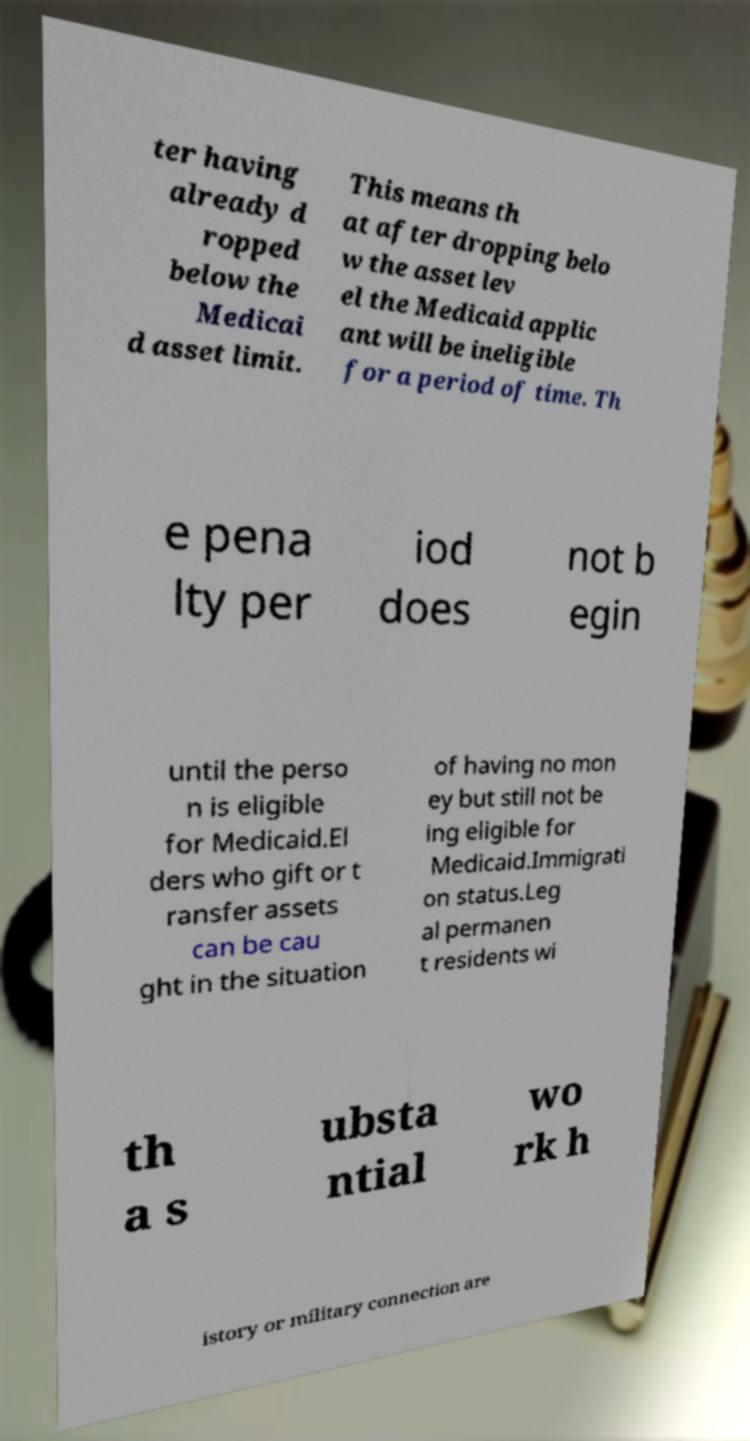Can you accurately transcribe the text from the provided image for me? ter having already d ropped below the Medicai d asset limit. This means th at after dropping belo w the asset lev el the Medicaid applic ant will be ineligible for a period of time. Th e pena lty per iod does not b egin until the perso n is eligible for Medicaid.El ders who gift or t ransfer assets can be cau ght in the situation of having no mon ey but still not be ing eligible for Medicaid.Immigrati on status.Leg al permanen t residents wi th a s ubsta ntial wo rk h istory or military connection are 